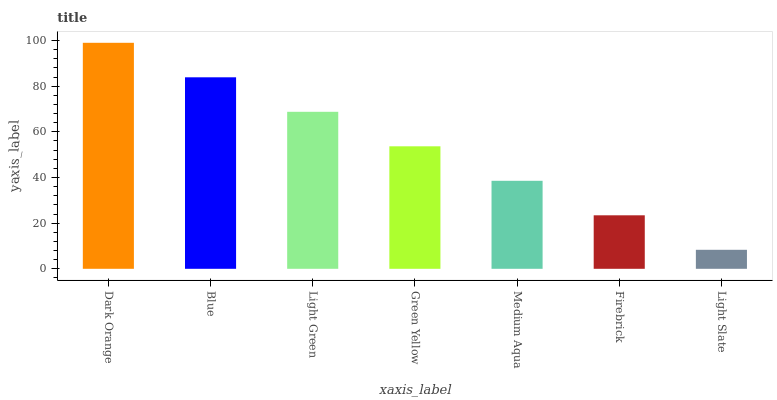Is Light Slate the minimum?
Answer yes or no. Yes. Is Dark Orange the maximum?
Answer yes or no. Yes. Is Blue the minimum?
Answer yes or no. No. Is Blue the maximum?
Answer yes or no. No. Is Dark Orange greater than Blue?
Answer yes or no. Yes. Is Blue less than Dark Orange?
Answer yes or no. Yes. Is Blue greater than Dark Orange?
Answer yes or no. No. Is Dark Orange less than Blue?
Answer yes or no. No. Is Green Yellow the high median?
Answer yes or no. Yes. Is Green Yellow the low median?
Answer yes or no. Yes. Is Light Slate the high median?
Answer yes or no. No. Is Dark Orange the low median?
Answer yes or no. No. 